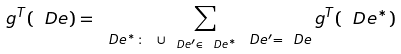<formula> <loc_0><loc_0><loc_500><loc_500>g ^ { T } ( \ D e ) = \sum _ { \ D e ^ { * } \colon \ \cup _ { \ D e ^ { \prime } \in \ D e ^ { * } } \ D e ^ { \prime } = \ D e } g ^ { T } ( \ D e ^ { * } )</formula> 